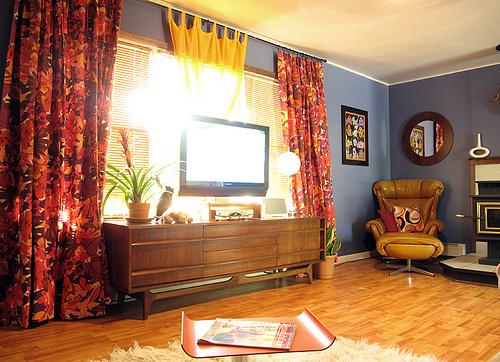What room is this?
Be succinct. Living room. What is to the far right of the photo?
Be succinct. Chair. Is the television on?
Concise answer only. Yes. What is the floor made out of?
Quick response, please. Wood. What kind of business is this picture likely to have been taken at?
Quick response, please. Home. 